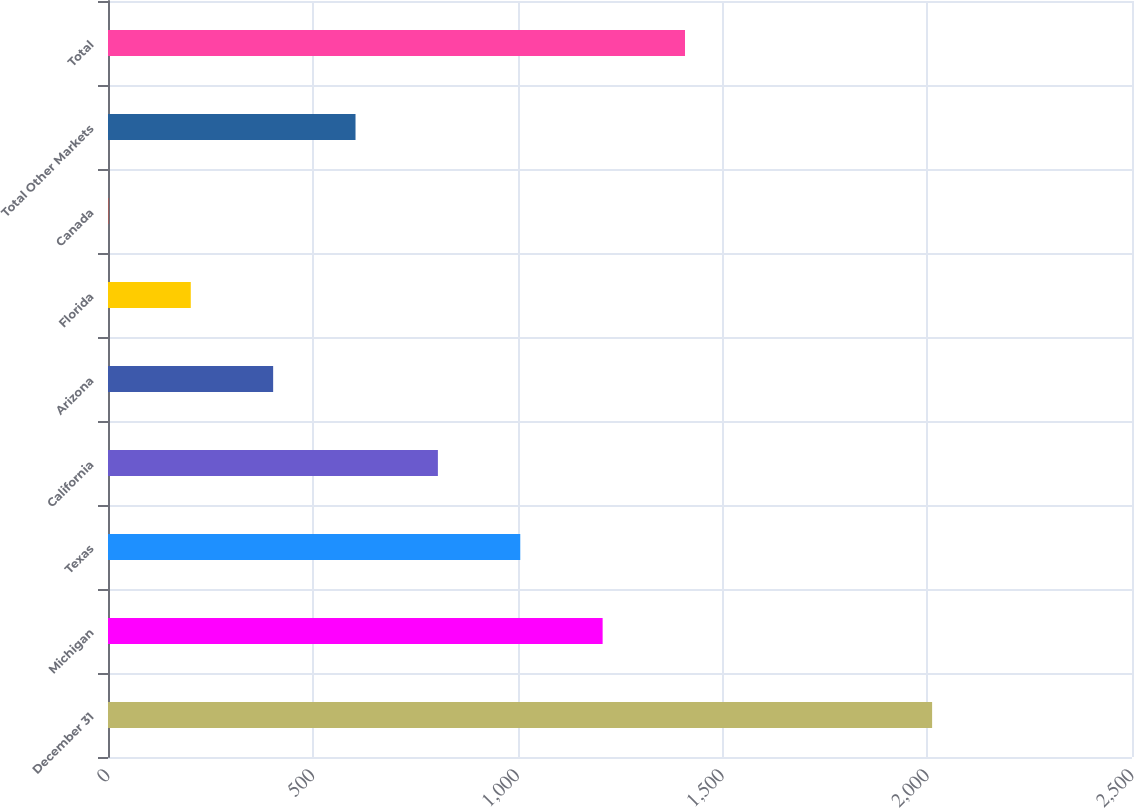<chart> <loc_0><loc_0><loc_500><loc_500><bar_chart><fcel>December 31<fcel>Michigan<fcel>Texas<fcel>California<fcel>Arizona<fcel>Florida<fcel>Canada<fcel>Total Other Markets<fcel>Total<nl><fcel>2012<fcel>1207.6<fcel>1006.5<fcel>805.4<fcel>403.2<fcel>202.1<fcel>1<fcel>604.3<fcel>1408.7<nl></chart> 